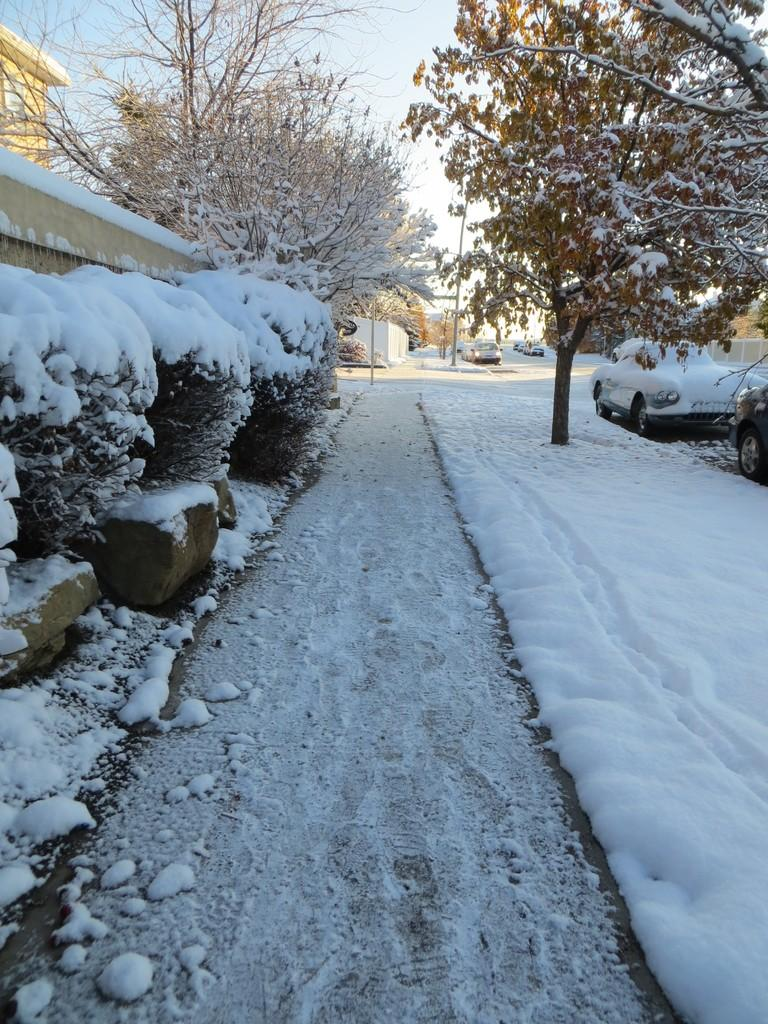What is the predominant weather condition in the image? There is snow in the image, indicating a cold and wintry condition. What can be seen on the left side of the image? There are trees and a wall on the left side of the image. What is visible at the top of the image? The sky is visible at the top of the image. What is the weight of the nation depicted in the image? There is no nation depicted in the image, as it features snow, trees, and a wall. Can you identify any patches on the trees in the image? There is no mention of patches on the trees in the image; only the presence of snow, trees, and a wall is noted. 